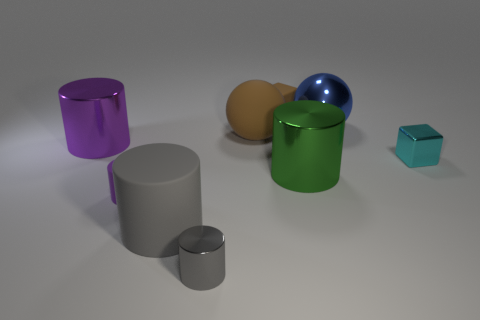What number of rubber things are blue spheres or small cyan objects?
Keep it short and to the point. 0. Is the material of the gray object that is in front of the large gray rubber cylinder the same as the purple cylinder that is to the right of the purple shiny object?
Ensure brevity in your answer.  No. There is a tiny cylinder that is the same material as the big brown object; what color is it?
Make the answer very short. Purple. Is the number of cyan metallic cubes to the left of the cyan object greater than the number of small purple rubber things that are behind the matte ball?
Offer a very short reply. No. Is there a big brown metal ball?
Keep it short and to the point. No. There is a big cylinder that is the same color as the small matte cylinder; what is it made of?
Your answer should be very brief. Metal. How many things are either purple objects or brown things?
Provide a short and direct response. 4. Is there a ball of the same color as the small matte cube?
Your response must be concise. Yes. There is a shiny object right of the big blue object; what number of cyan cubes are in front of it?
Give a very brief answer. 0. Is the number of spheres greater than the number of cyan cylinders?
Provide a short and direct response. Yes. 